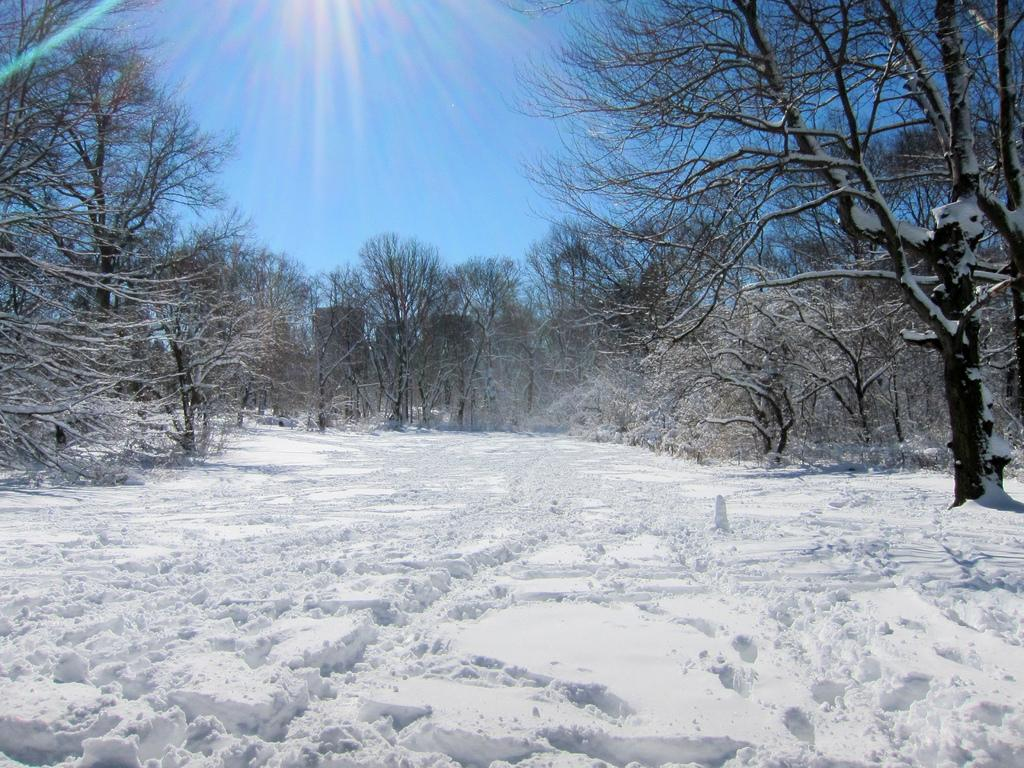What type of natural environment is depicted in the image? The image contains a surface of snow. What can be seen in the background of the image? There are trees and the sky visible in the background of the image. What type of stove can be seen in the image? There is no stove present in the image; it features a snowy surface and trees in the background. 